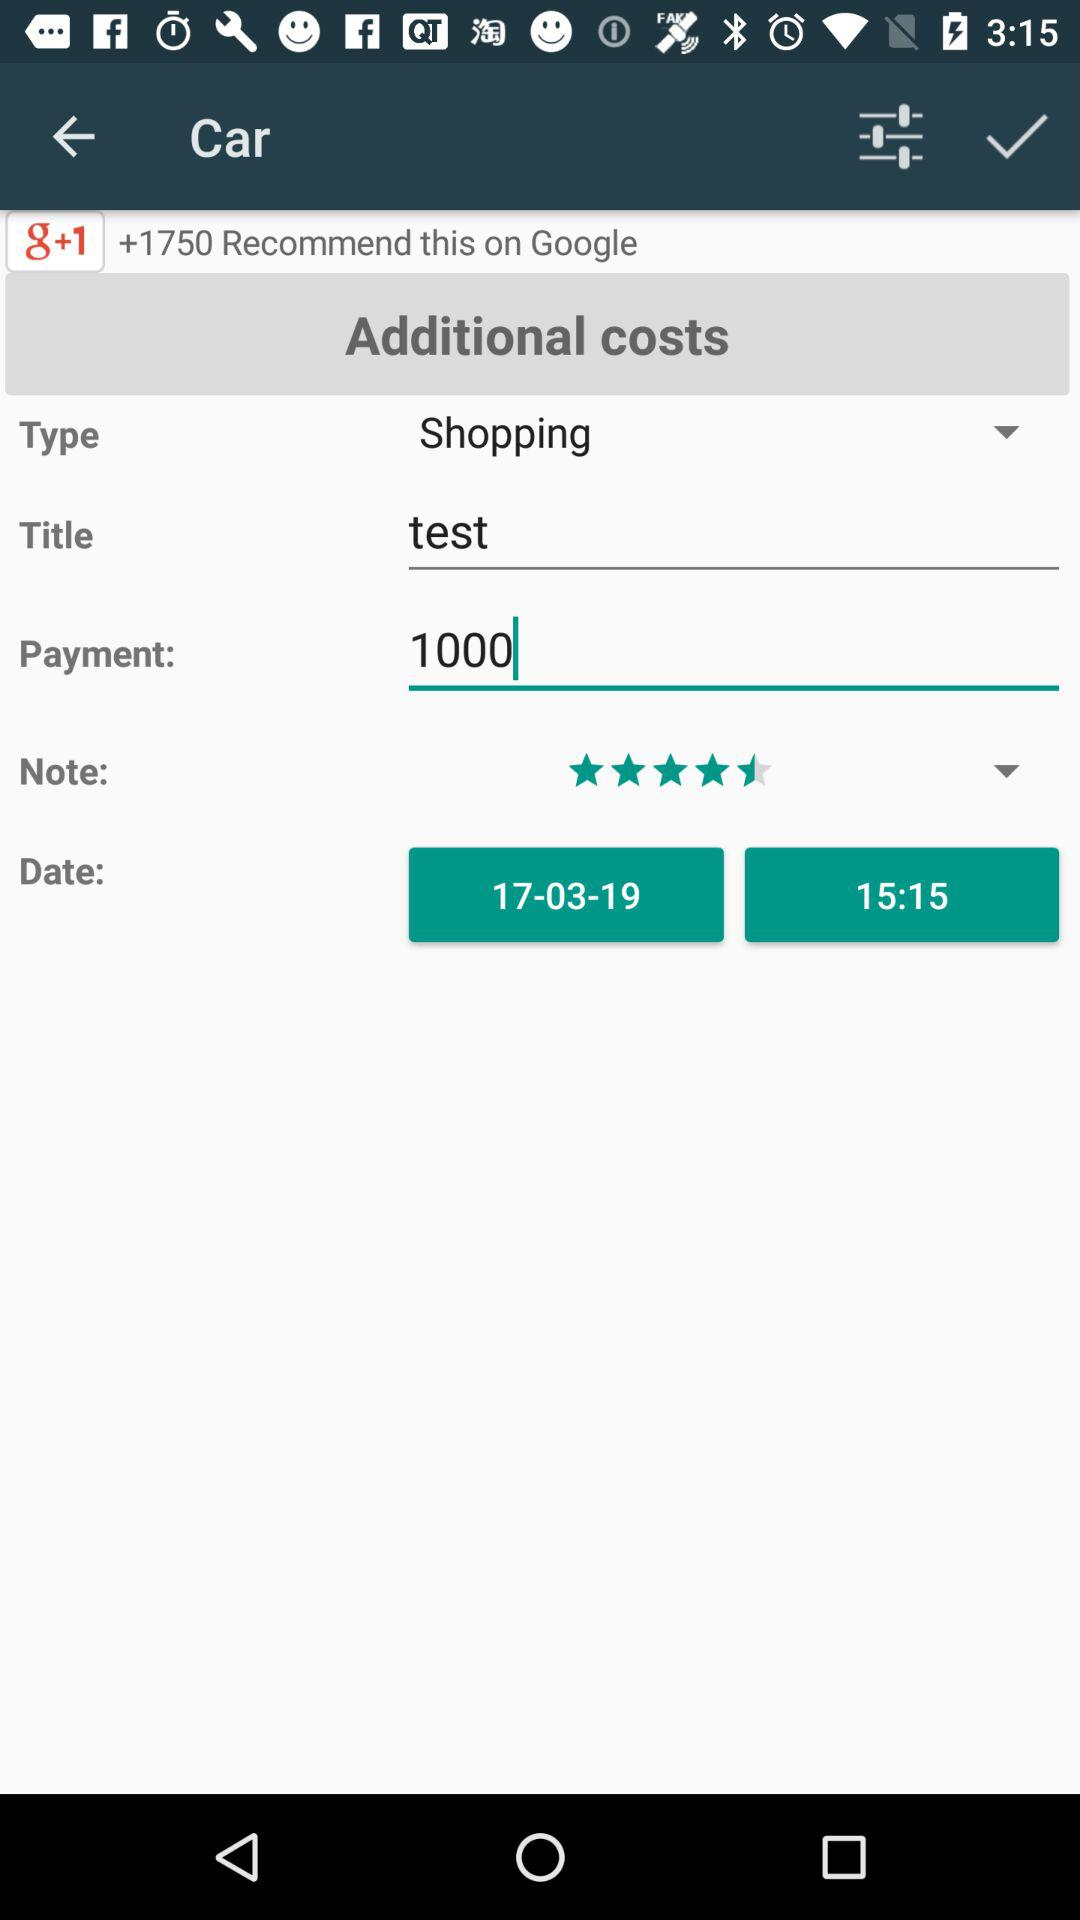How much is the payment amount? The payment amount is 1000. 